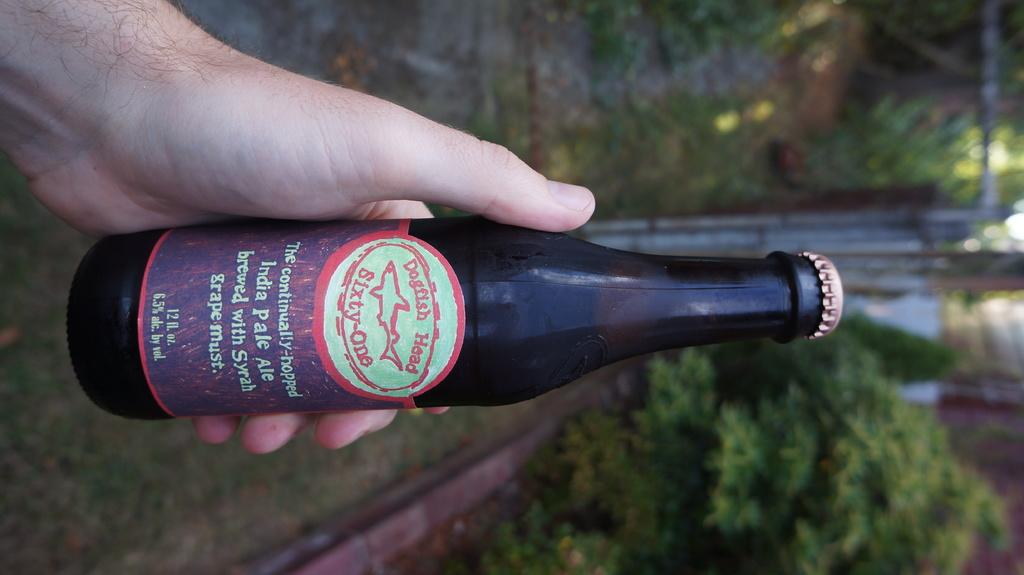<image>
Provide a brief description of the given image. A hand is holding a bottle of Dogfish Head IPA outdoors. 